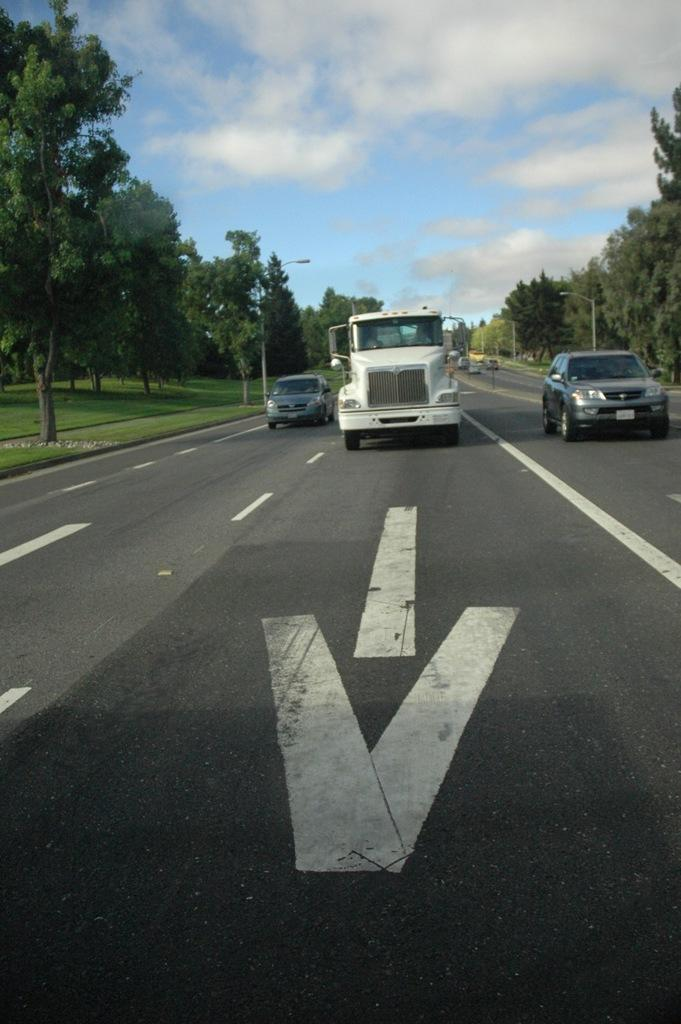What is in the foreground of the image? There is a road in the foreground of the image. What can be seen in the center of the image? Trees are present in the center of the image, and vehicles are moving on the road. What is visible at the top of the image? The sky is visible at the top of the image. Where are the pies being stored in the image? There are no pies present in the image. Can you describe the type of zipper used on the vehicles in the image? There are no zippers present on the vehicles in the image. 